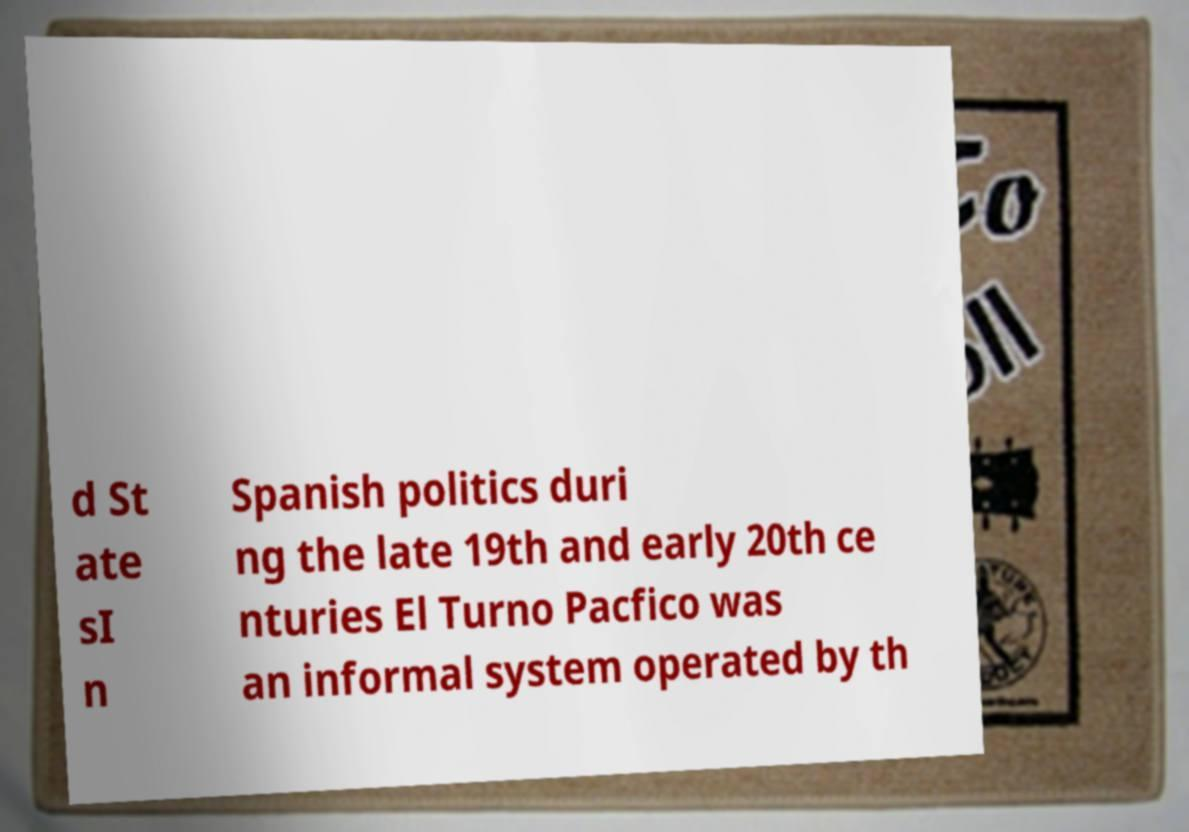Please read and relay the text visible in this image. What does it say? d St ate sI n Spanish politics duri ng the late 19th and early 20th ce nturies El Turno Pacfico was an informal system operated by th 